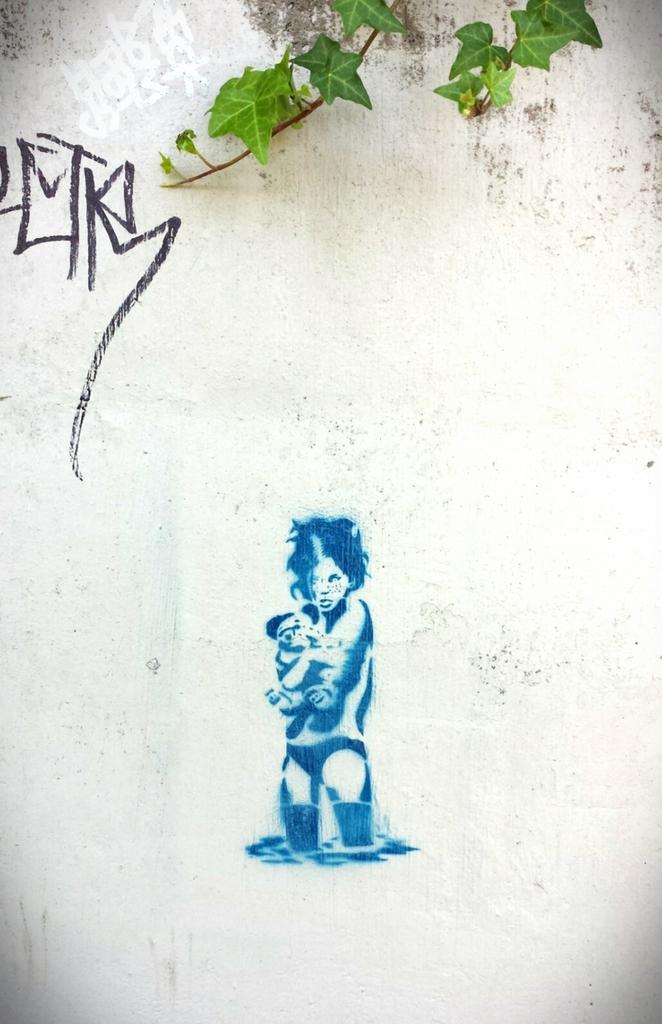What color is the wall in the image? The wall in the image is white. What can be seen on the wall? There is a painting on the wall. What else is present in the image besides the wall and painting? There are leaves in the image. What type of event is taking place in the image? There is no indication of an event taking place in the image. Are there any curtains visible in the image? There is no mention of curtains in the provided facts, and they are not visible in the image. 